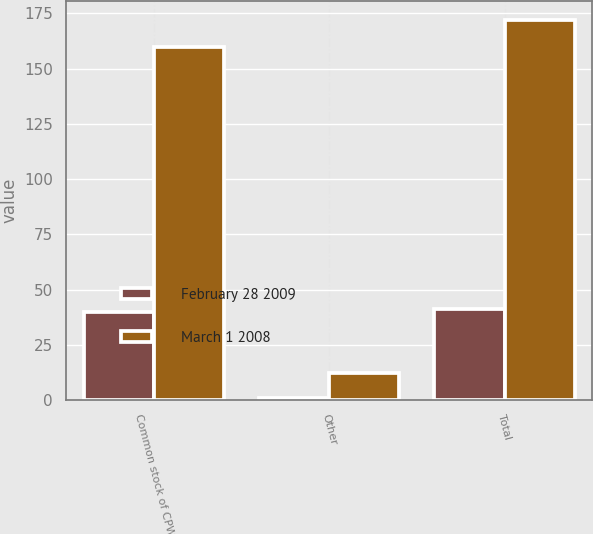Convert chart. <chart><loc_0><loc_0><loc_500><loc_500><stacked_bar_chart><ecel><fcel>Common stock of CPW<fcel>Other<fcel>Total<nl><fcel>February 28 2009<fcel>40<fcel>1<fcel>41<nl><fcel>March 1 2008<fcel>160<fcel>12<fcel>172<nl></chart> 